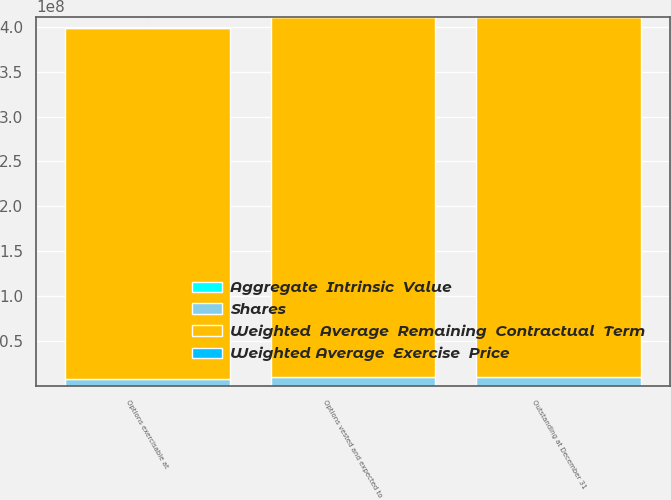Convert chart to OTSL. <chart><loc_0><loc_0><loc_500><loc_500><stacked_bar_chart><ecel><fcel>Outstanding at December 31<fcel>Options vested and expected to<fcel>Options exercisable at<nl><fcel>Shares<fcel>9.72531e+06<fcel>9.71577e+06<fcel>7.59329e+06<nl><fcel>Aggregate  Intrinsic  Value<fcel>49.41<fcel>49.35<fcel>35.68<nl><fcel>Weighted Average  Exercise  Price<fcel>3.8<fcel>3.8<fcel>2.5<nl><fcel>Weighted  Average  Remaining  Contractual  Term<fcel>4.01722e+08<fcel>4.01722e+08<fcel>3.90939e+08<nl></chart> 